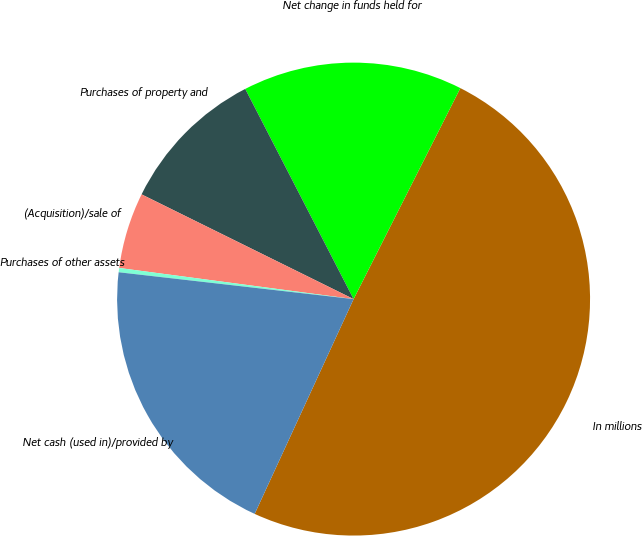Convert chart to OTSL. <chart><loc_0><loc_0><loc_500><loc_500><pie_chart><fcel>In millions<fcel>Net change in funds held for<fcel>Purchases of property and<fcel>(Acquisition)/sale of<fcel>Purchases of other assets<fcel>Net cash (used in)/provided by<nl><fcel>49.41%<fcel>15.03%<fcel>10.12%<fcel>5.2%<fcel>0.29%<fcel>19.94%<nl></chart> 